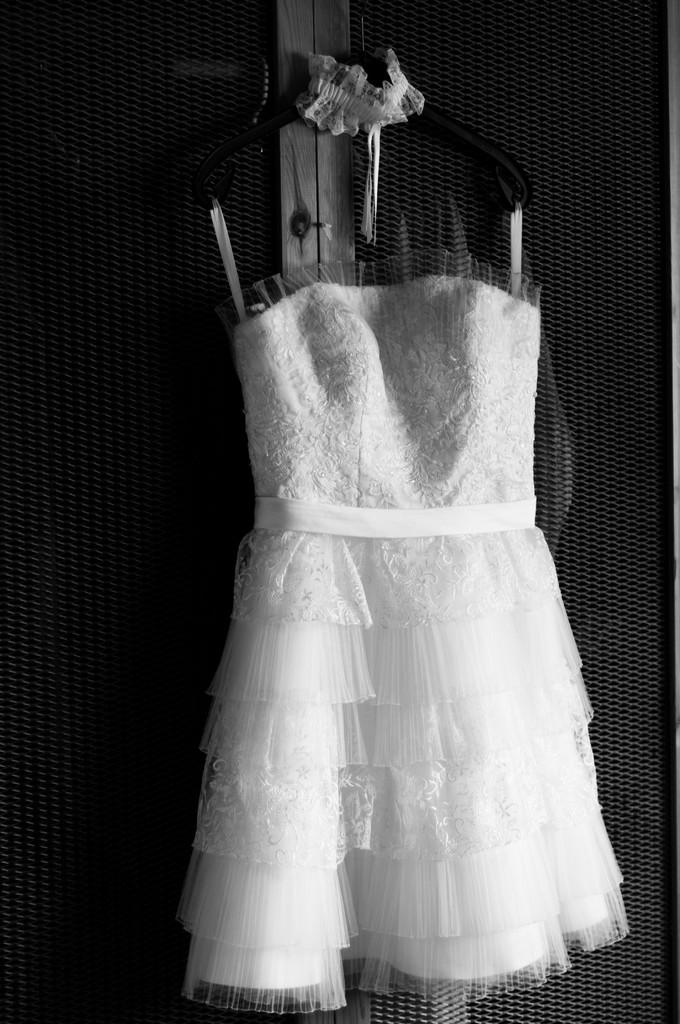What is the color scheme of the image? The image is black and white. What can be seen hanging on the wall in the image? There is a frock hanging on a wall in the image. Can you see a porter carrying a truck up a hill in the image? No, there is no porter, truck, or hill present in the image. The image only features a black and white frock hanging on a wall. 